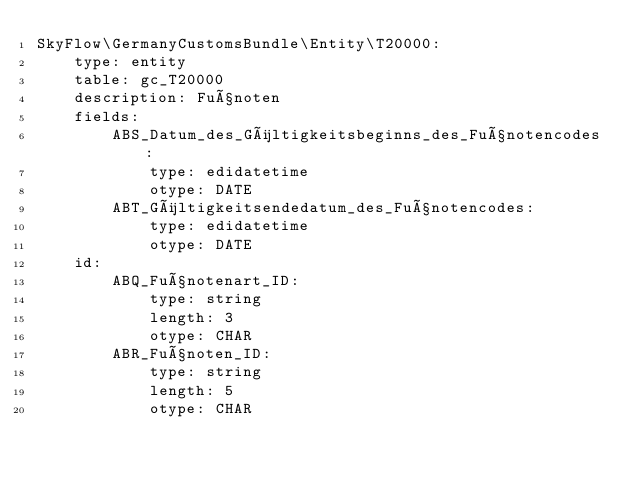<code> <loc_0><loc_0><loc_500><loc_500><_YAML_>SkyFlow\GermanyCustomsBundle\Entity\T20000:
    type: entity
    table: gc_T20000
    description: Fußnoten
    fields:
        ABS_Datum_des_Gültigkeitsbeginns_des_Fußnotencodes:
            type: edidatetime
            otype: DATE
        ABT_Gültigkeitsendedatum_des_Fußnotencodes:
            type: edidatetime
            otype: DATE
    id:
        ABQ_Fußnotenart_ID:
            type: string
            length: 3
            otype: CHAR
        ABR_Fußnoten_ID:
            type: string
            length: 5
            otype: CHAR
</code> 